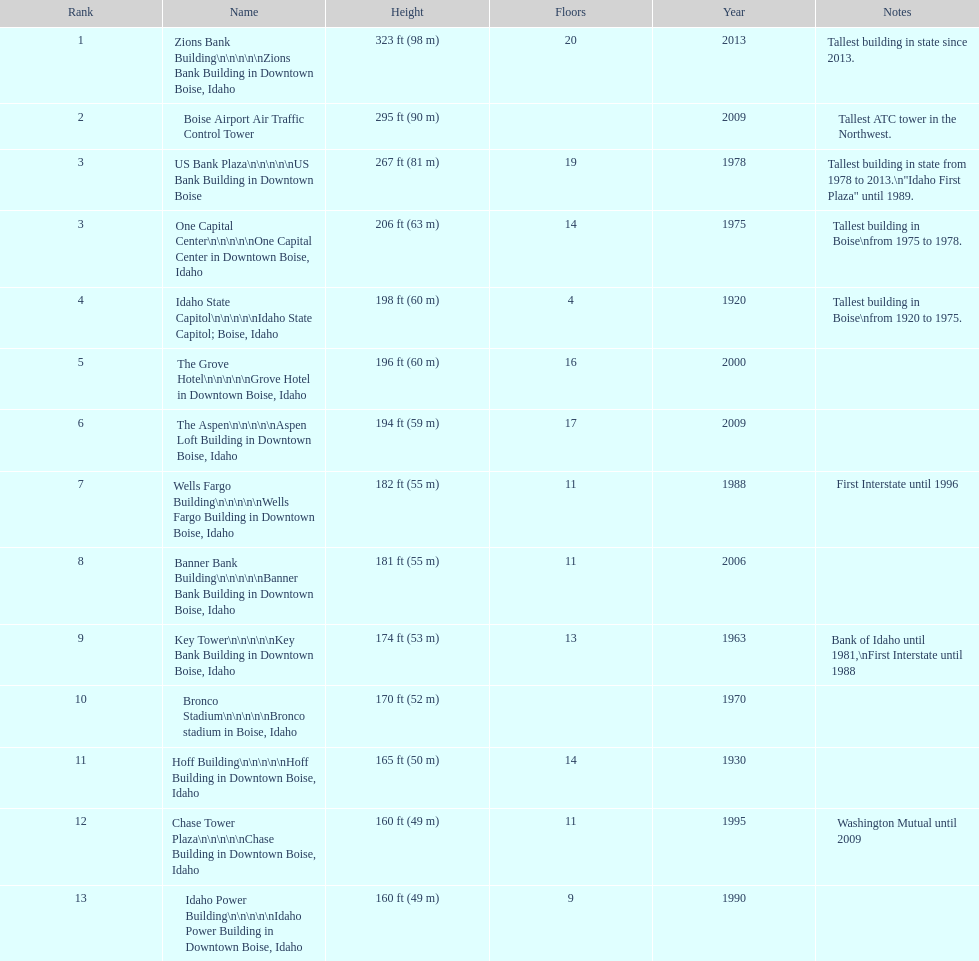How many buildings have at least ten floors? 10. 